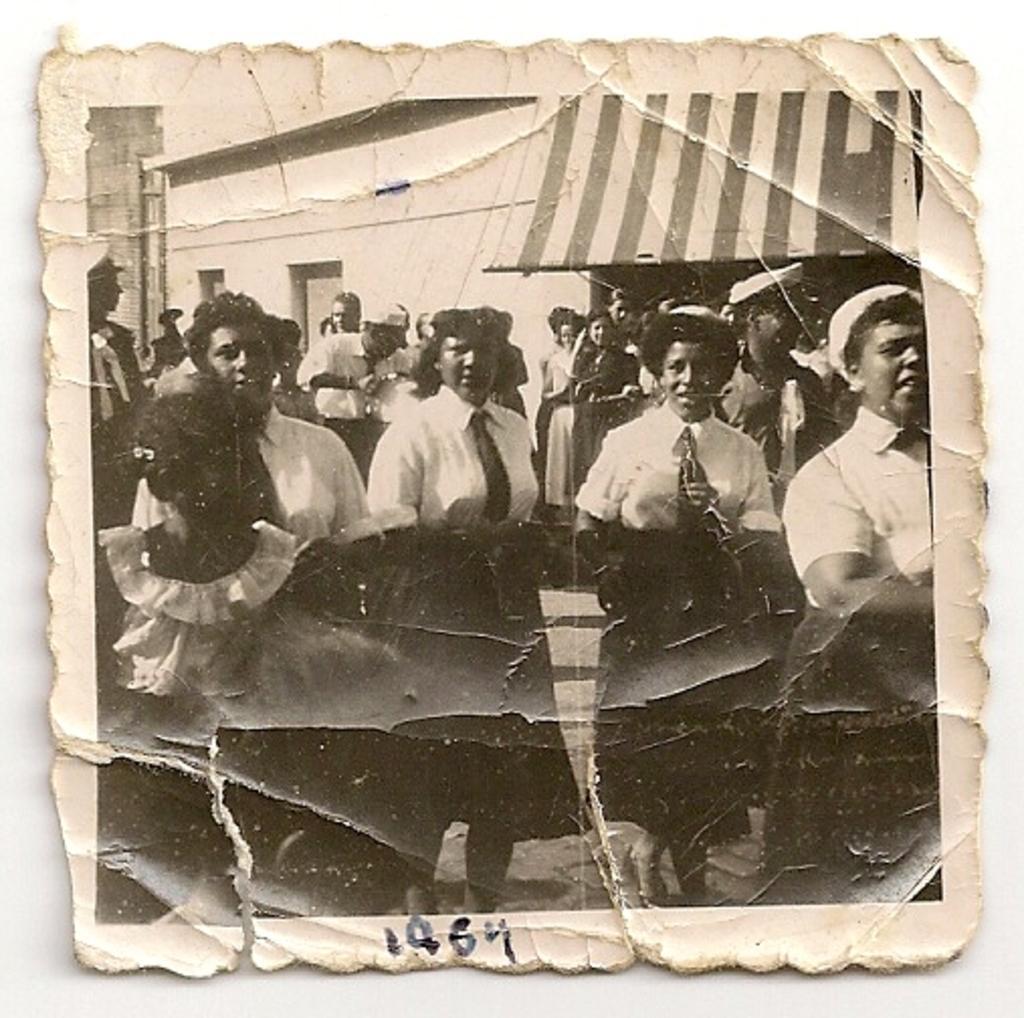Please provide a concise description of this image. In this image we can see a photograph. In the center of the image there are people wearing uniforms. In the background there is a shed. 